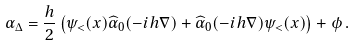Convert formula to latex. <formula><loc_0><loc_0><loc_500><loc_500>\alpha _ { \Delta } = \frac { h } { 2 } \left ( \psi _ { < } ( x ) \widehat { \alpha } _ { 0 } ( - i h \nabla ) + \widehat { \alpha } _ { 0 } ( - i h \nabla ) \psi _ { < } ( x ) \right ) + \phi \, .</formula> 